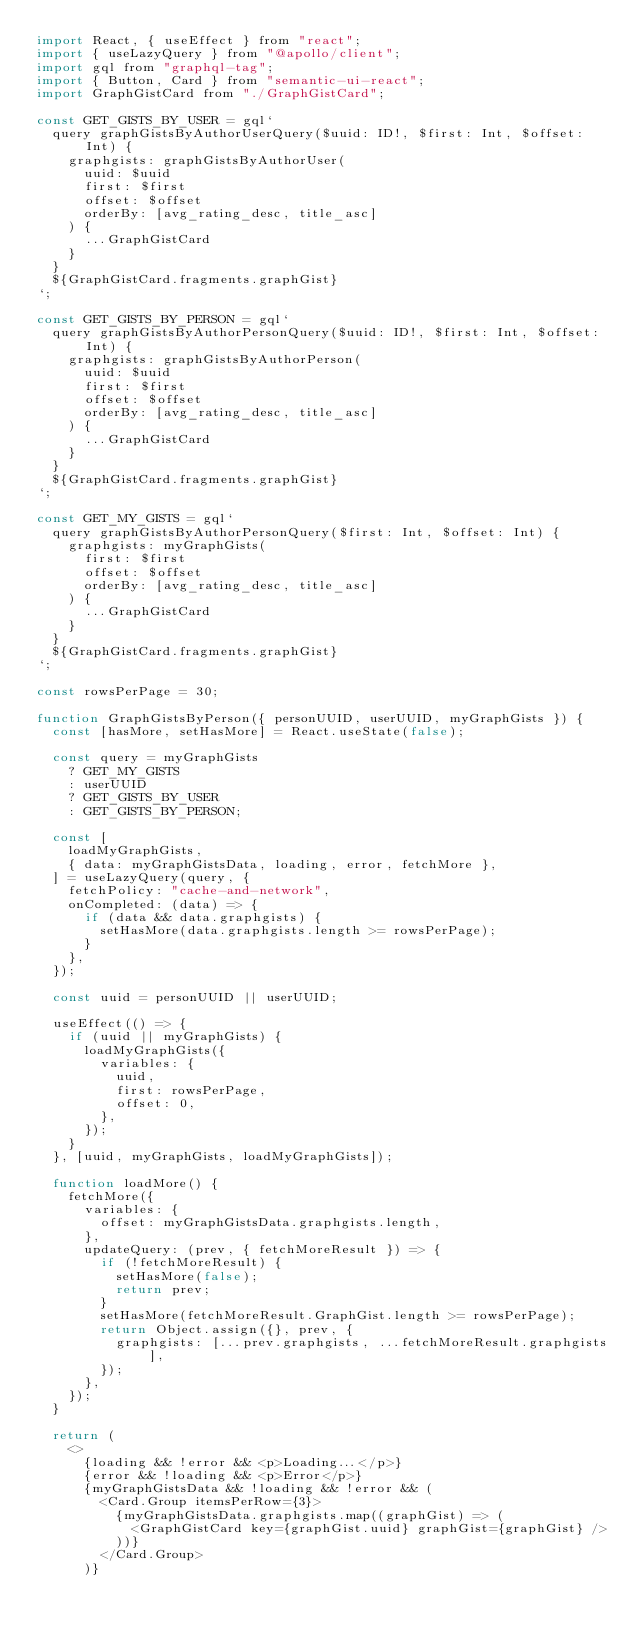<code> <loc_0><loc_0><loc_500><loc_500><_JavaScript_>import React, { useEffect } from "react";
import { useLazyQuery } from "@apollo/client";
import gql from "graphql-tag";
import { Button, Card } from "semantic-ui-react";
import GraphGistCard from "./GraphGistCard";

const GET_GISTS_BY_USER = gql`
  query graphGistsByAuthorUserQuery($uuid: ID!, $first: Int, $offset: Int) {
    graphgists: graphGistsByAuthorUser(
      uuid: $uuid
      first: $first
      offset: $offset
      orderBy: [avg_rating_desc, title_asc]
    ) {
      ...GraphGistCard
    }
  }
  ${GraphGistCard.fragments.graphGist}
`;

const GET_GISTS_BY_PERSON = gql`
  query graphGistsByAuthorPersonQuery($uuid: ID!, $first: Int, $offset: Int) {
    graphgists: graphGistsByAuthorPerson(
      uuid: $uuid
      first: $first
      offset: $offset
      orderBy: [avg_rating_desc, title_asc]
    ) {
      ...GraphGistCard
    }
  }
  ${GraphGistCard.fragments.graphGist}
`;

const GET_MY_GISTS = gql`
  query graphGistsByAuthorPersonQuery($first: Int, $offset: Int) {
    graphgists: myGraphGists(
      first: $first
      offset: $offset
      orderBy: [avg_rating_desc, title_asc]
    ) {
      ...GraphGistCard
    }
  }
  ${GraphGistCard.fragments.graphGist}
`;

const rowsPerPage = 30;

function GraphGistsByPerson({ personUUID, userUUID, myGraphGists }) {
  const [hasMore, setHasMore] = React.useState(false);

  const query = myGraphGists
    ? GET_MY_GISTS
    : userUUID
    ? GET_GISTS_BY_USER
    : GET_GISTS_BY_PERSON;

  const [
    loadMyGraphGists,
    { data: myGraphGistsData, loading, error, fetchMore },
  ] = useLazyQuery(query, {
    fetchPolicy: "cache-and-network",
    onCompleted: (data) => {
      if (data && data.graphgists) {
        setHasMore(data.graphgists.length >= rowsPerPage);
      }
    },
  });

  const uuid = personUUID || userUUID;

  useEffect(() => {
    if (uuid || myGraphGists) {
      loadMyGraphGists({
        variables: {
          uuid,
          first: rowsPerPage,
          offset: 0,
        },
      });
    }
  }, [uuid, myGraphGists, loadMyGraphGists]);

  function loadMore() {
    fetchMore({
      variables: {
        offset: myGraphGistsData.graphgists.length,
      },
      updateQuery: (prev, { fetchMoreResult }) => {
        if (!fetchMoreResult) {
          setHasMore(false);
          return prev;
        }
        setHasMore(fetchMoreResult.GraphGist.length >= rowsPerPage);
        return Object.assign({}, prev, {
          graphgists: [...prev.graphgists, ...fetchMoreResult.graphgists],
        });
      },
    });
  }

  return (
    <>
      {loading && !error && <p>Loading...</p>}
      {error && !loading && <p>Error</p>}
      {myGraphGistsData && !loading && !error && (
        <Card.Group itemsPerRow={3}>
          {myGraphGistsData.graphgists.map((graphGist) => (
            <GraphGistCard key={graphGist.uuid} graphGist={graphGist} />
          ))}
        </Card.Group>
      )}</code> 